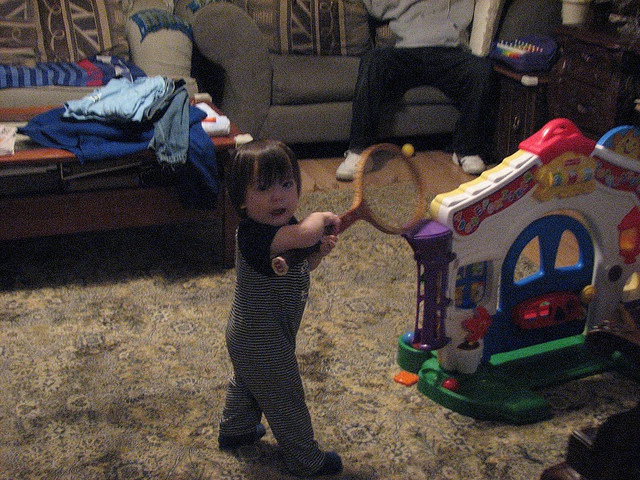Describe the objects in this image and their specific colors. I can see people in purple, black, gray, navy, and maroon tones, couch in purple, gray, black, and olive tones, couch in purple, black, gray, and darkgreen tones, people in purple, black, gray, and darkgray tones, and tennis racket in purple, gray, olive, black, and maroon tones in this image. 